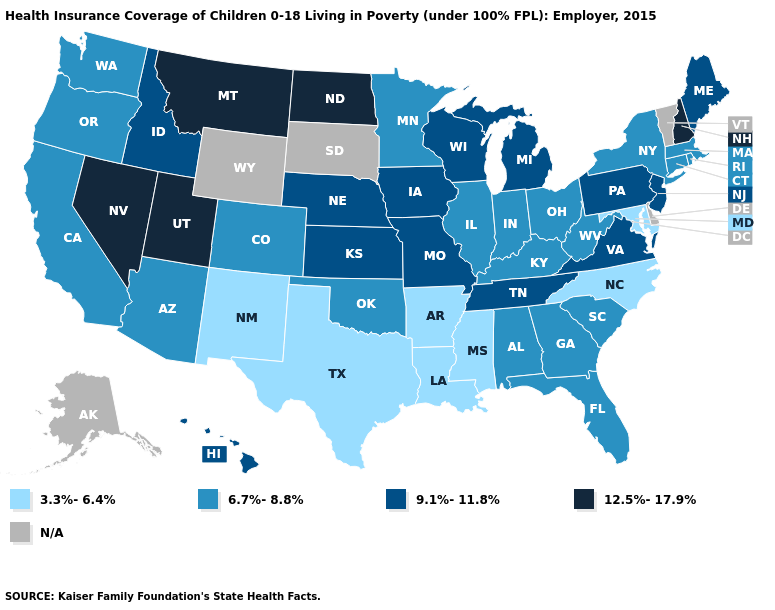What is the value of Washington?
Be succinct. 6.7%-8.8%. Among the states that border North Carolina , which have the lowest value?
Answer briefly. Georgia, South Carolina. Among the states that border Maine , which have the lowest value?
Write a very short answer. New Hampshire. Among the states that border Massachusetts , which have the highest value?
Be succinct. New Hampshire. What is the lowest value in the MidWest?
Answer briefly. 6.7%-8.8%. Name the states that have a value in the range 9.1%-11.8%?
Keep it brief. Hawaii, Idaho, Iowa, Kansas, Maine, Michigan, Missouri, Nebraska, New Jersey, Pennsylvania, Tennessee, Virginia, Wisconsin. Name the states that have a value in the range 12.5%-17.9%?
Give a very brief answer. Montana, Nevada, New Hampshire, North Dakota, Utah. What is the value of Michigan?
Answer briefly. 9.1%-11.8%. What is the highest value in states that border Delaware?
Be succinct. 9.1%-11.8%. What is the value of South Dakota?
Keep it brief. N/A. What is the highest value in the West ?
Be succinct. 12.5%-17.9%. Among the states that border Massachusetts , which have the highest value?
Concise answer only. New Hampshire. Among the states that border Nevada , which have the highest value?
Concise answer only. Utah. 